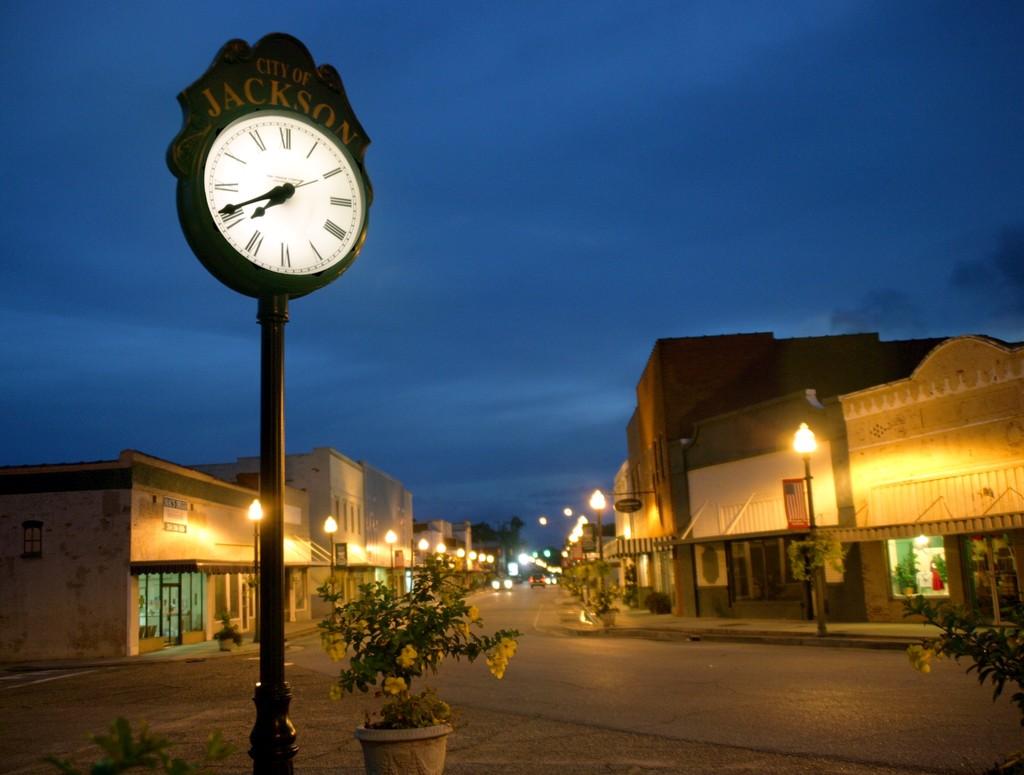What time does the clock say?
Your response must be concise. 7:41. 